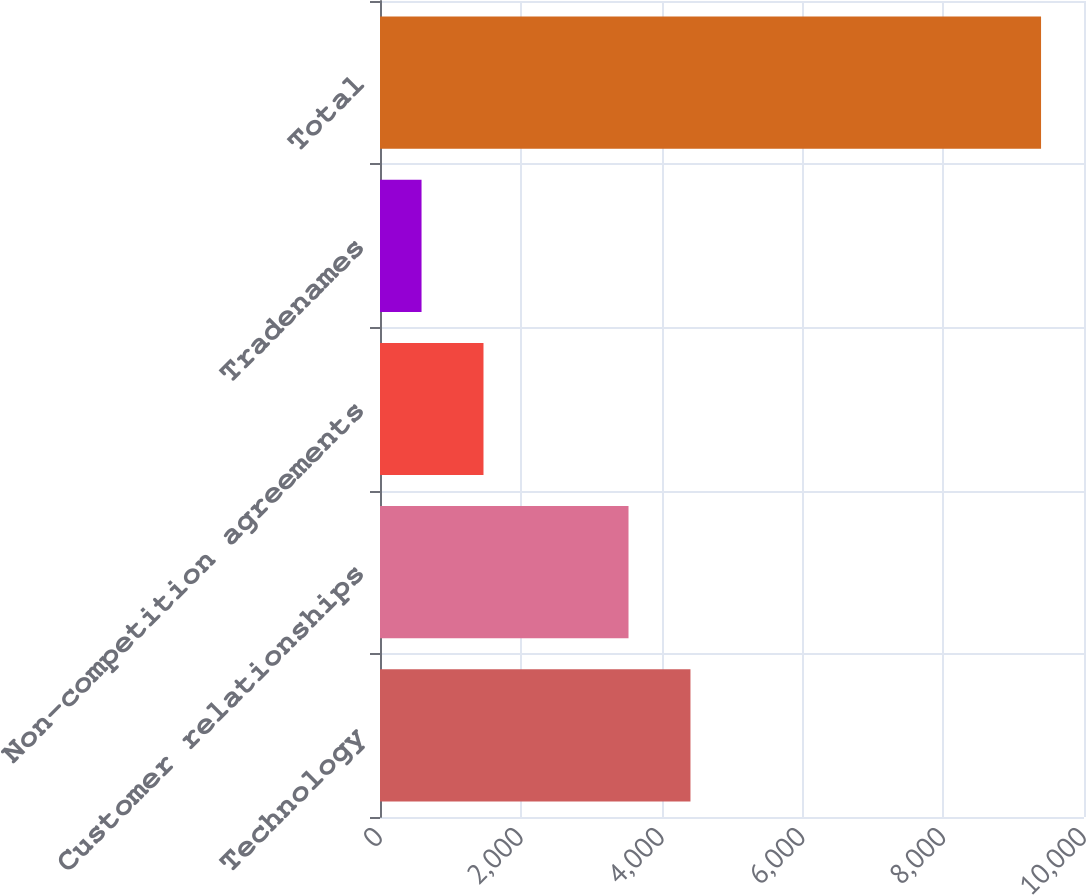Convert chart to OTSL. <chart><loc_0><loc_0><loc_500><loc_500><bar_chart><fcel>Technology<fcel>Customer relationships<fcel>Non-competition agreements<fcel>Tradenames<fcel>Total<nl><fcel>4410<fcel>3530<fcel>1470<fcel>590<fcel>9390<nl></chart> 